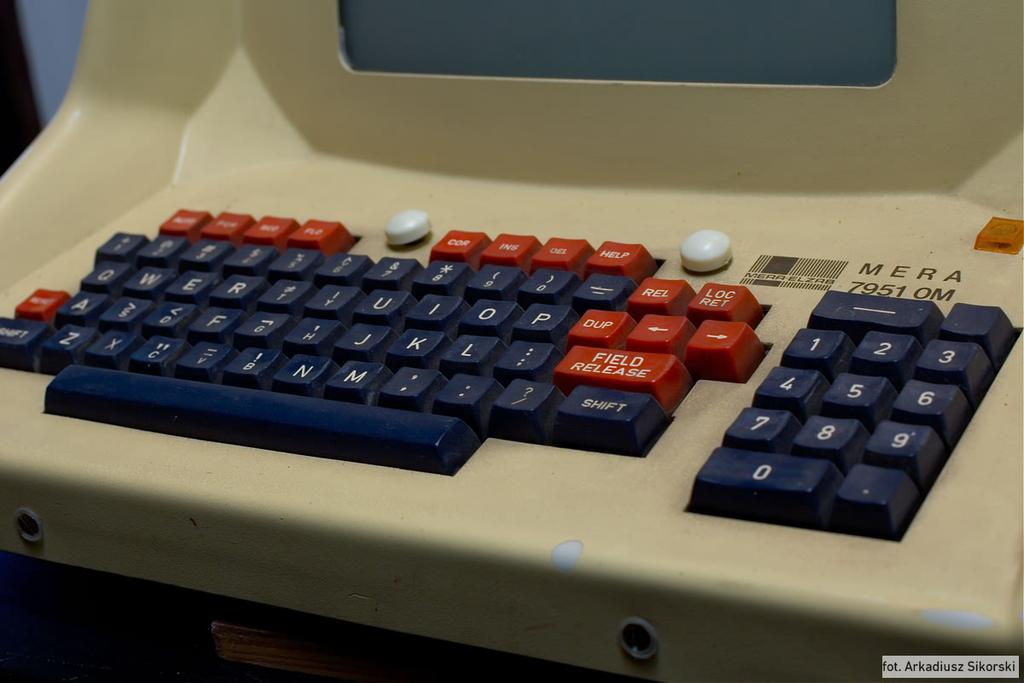<image>
Summarize the visual content of the image. A black and red keyboard for a Mera 7951 0m. 